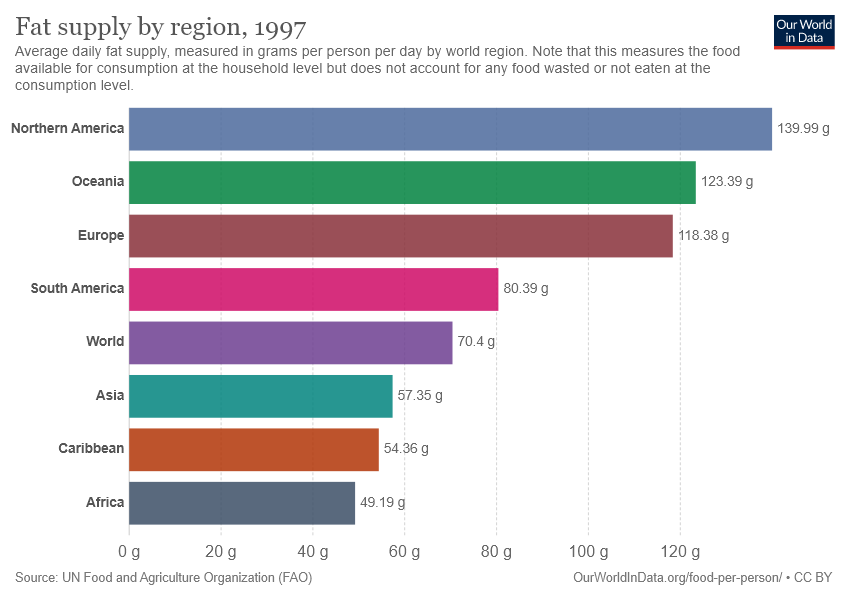Outline some significant characteristics in this image. The sum of the fat supply among the three countries with the lowest values is 160.9. The fat supply level in Asia is 57.35. 